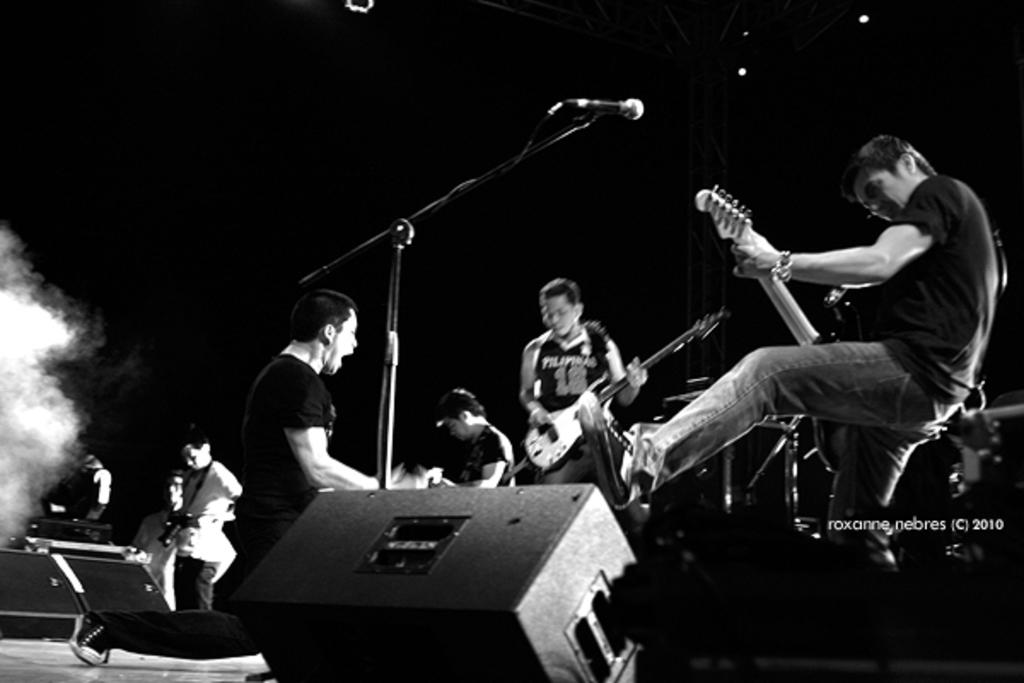What are the people in the image doing? The people in the image are playing musical instruments. Can you identify any specific musical instrument in the image? Yes, there is a guitar in the image. What device is present for amplifying sound or facilitating vocal performance? There is a microphone in the image. Is there any additional information or branding present in the image? Yes, there is a watermark in the image. What word is being balanced on the tip of the guitar in the image? There is no word being balanced on the tip of the guitar in the image; it is not present. 